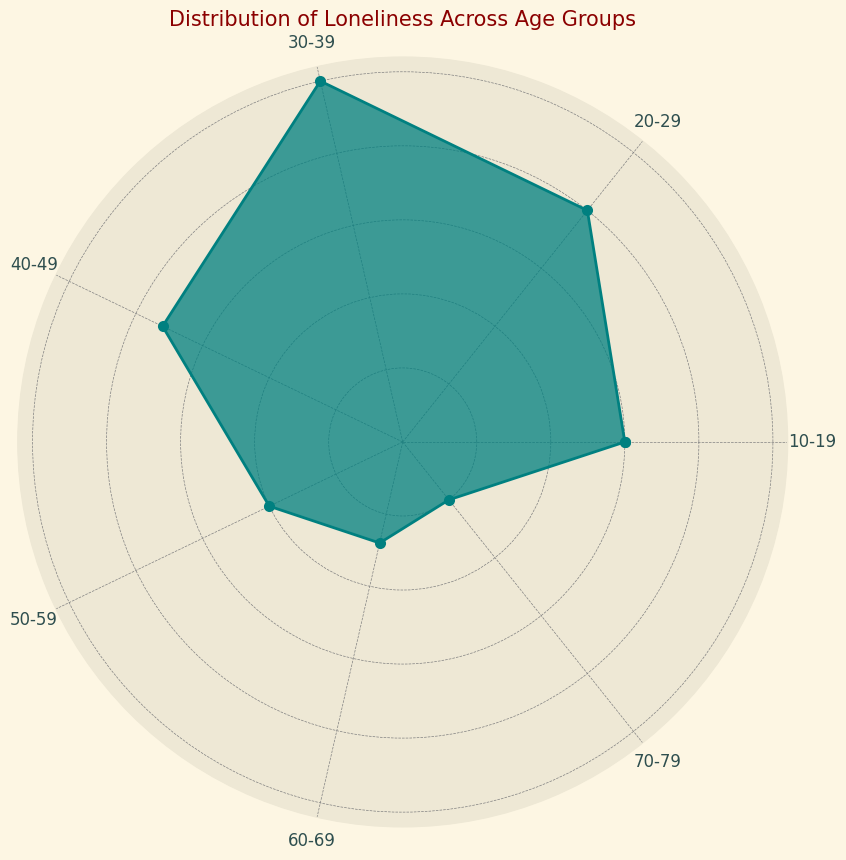Which age group has the highest percentage of loneliness? By looking at the height of the visual segments for each age group, we see that the '30-39' age group has the longest segment, indicating the highest percentage.
Answer: 30-39 Which age group has the lowest percentage of loneliness? By observing the shortest visual segment in the chart, the '70-79' age group has the smallest segment, indicating the lowest percentage.
Answer: 70-79 What is the difference in percentage of loneliness between the age groups 20-29 and 50-59? The percentage for 20-29 is 20%, and for 50-59 it's 10%. The difference is calculated as 20% - 10% = 10%.
Answer: 10% What is the average percentage of loneliness across all age groups? First, sum up the percentages (15 + 20 + 25 + 18 + 10 + 7 + 5 = 100). Then, divide by the number of age groups (7). The average is 100 / 7 ≈ 14.29%.
Answer: 14.29% Which age groups have a percentage of loneliness greater than the overall average? The overall average percentage of loneliness is approximately 14.29%. The age groups 20-29 (20%), 30-39 (25%), and 40-49 (18%) have percentages greater than this average.
Answer: 20-29, 30-39, 40-49 How does the percentage of loneliness change from age group 40-49 to 50-59? The percentage for 40-49 is 18%, and for 50-59 it is 10%. The change is calculated as 18% - 10% = 8%.
Answer: Decreases by 8% What is the median percentage of loneliness across the age groups? To find the median, list the percentages in ascending order: 5%, 7%, 10%, 15%, 18%, 20%, 25%. The median is the middle value, which is 15%.
Answer: 15% Which age group represents exactly one-fourth of the way through the data when ordered by percentage of loneliness? Ordering the percentages: 5%, 7%, 10%, 15%, 18%, 20%, 25%. One-fourth of the way through (1/4 * 7 = 1.75, rounding up to 2) is the second value, which is 7% belonging to the age group 60-69.
Answer: 60-69 